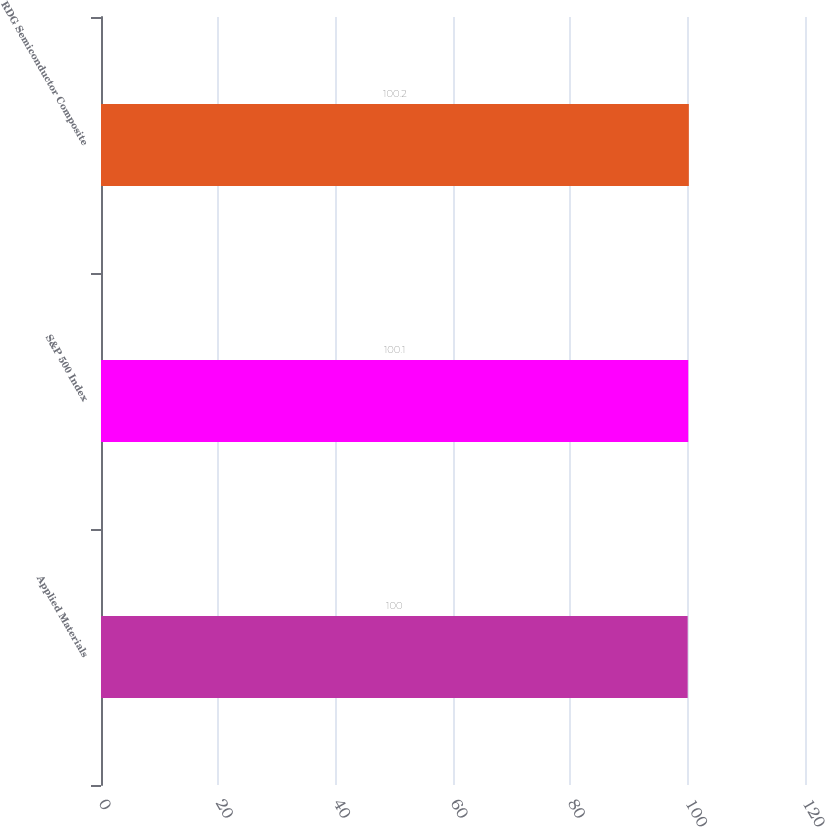Convert chart. <chart><loc_0><loc_0><loc_500><loc_500><bar_chart><fcel>Applied Materials<fcel>S&P 500 Index<fcel>RDG Semiconductor Composite<nl><fcel>100<fcel>100.1<fcel>100.2<nl></chart> 